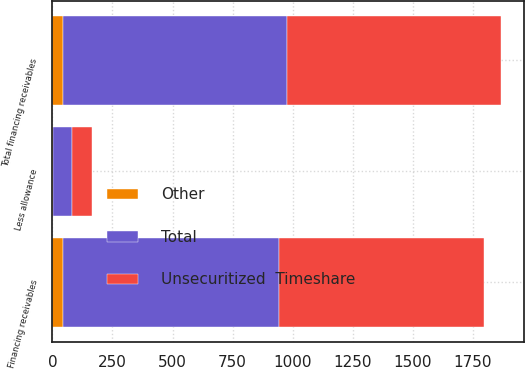<chart> <loc_0><loc_0><loc_500><loc_500><stacked_bar_chart><ecel><fcel>Financing receivables<fcel>Less allowance<fcel>Total financing receivables<nl><fcel>Unsecuritized  Timeshare<fcel>853<fcel>81<fcel>891<nl><fcel>Other<fcel>44<fcel>1<fcel>43<nl><fcel>Total<fcel>897<fcel>82<fcel>934<nl></chart> 